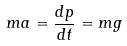<formula> <loc_0><loc_0><loc_500><loc_500>m a = \frac { d p } { d t } = m g</formula> 